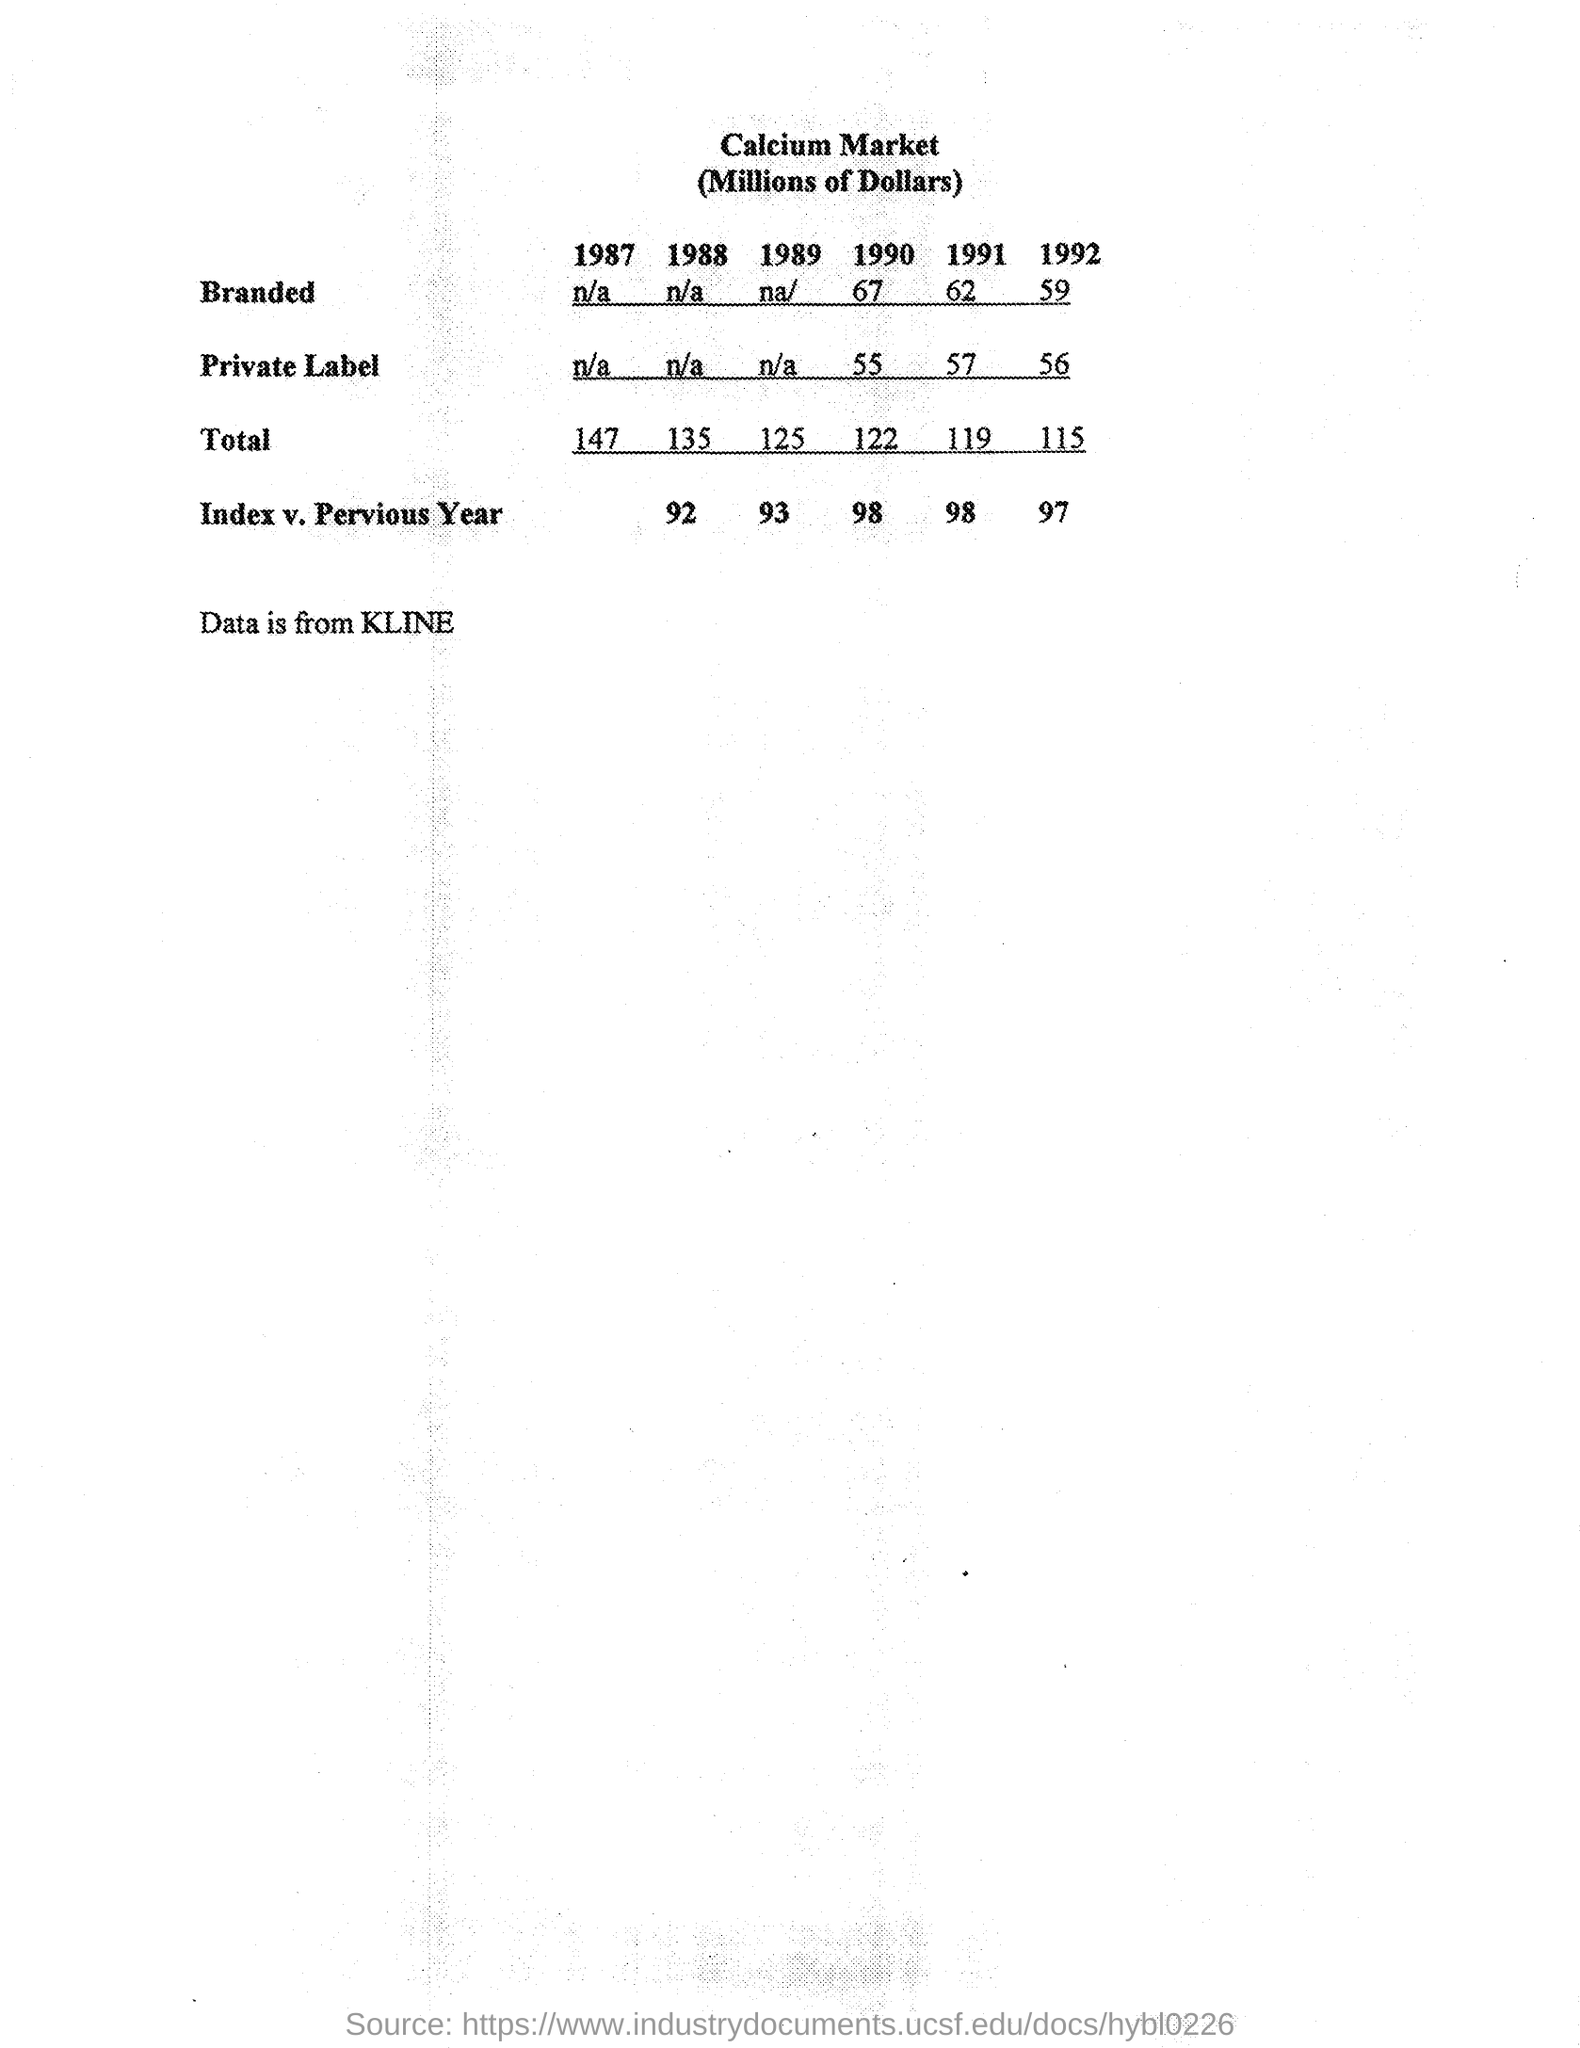What is the total calcium market ( millions of dollars ) for the year 1987
Provide a succinct answer. 147. What is the total calcium market ( millions of dollars ) for the year 1988
Your answer should be very brief. 135. What is the total calcium market ( millions of dollars ) for the year 1989
Your response must be concise. 125. What is the total calcium market ( millions of dollars ) for the year 1990
Your answer should be very brief. 122. What is the total calcium market ( millions of dollars ) for the year 1991
Your response must be concise. 119. What  is the index v . previous year for the year 1988
Your response must be concise. 92. What  is the index v . previous year for the year 1989
Make the answer very short. 93. What  is the index v . previous year for the year 1990
Offer a very short reply. 98. What  is the index v . previous year for the year 1992
Keep it short and to the point. 97. From where the data is collected
Provide a short and direct response. Data is from KLINE. 